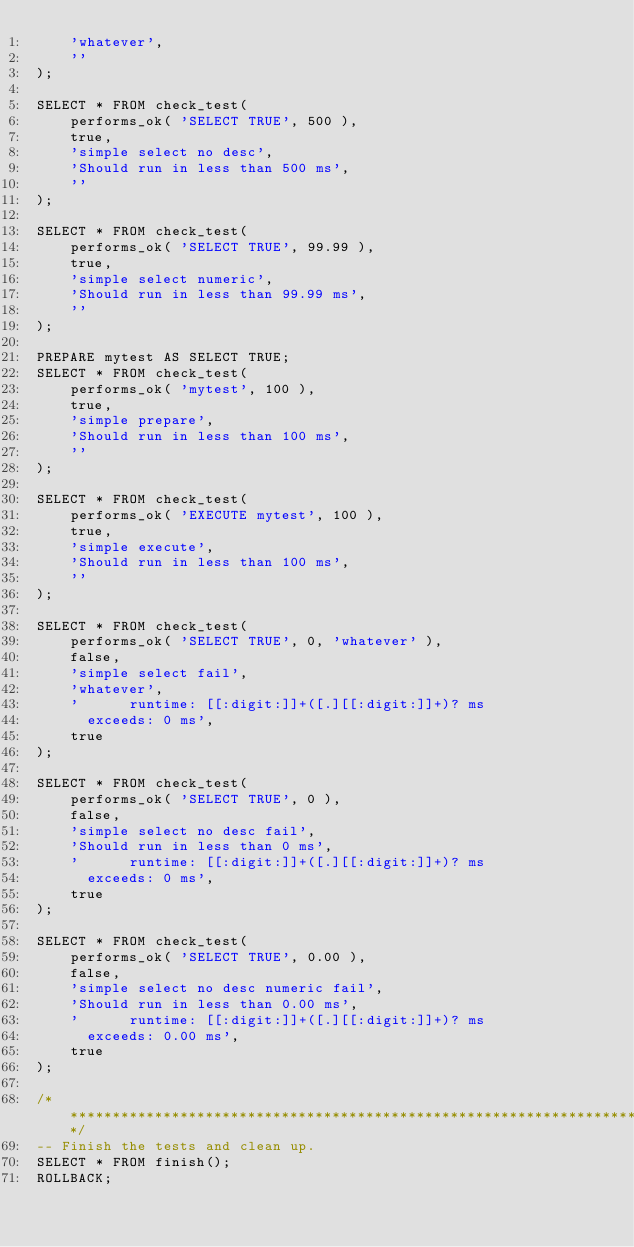<code> <loc_0><loc_0><loc_500><loc_500><_SQL_>    'whatever',
    ''
);

SELECT * FROM check_test(
    performs_ok( 'SELECT TRUE', 500 ),
    true,
    'simple select no desc',
    'Should run in less than 500 ms',
    ''
);

SELECT * FROM check_test(
    performs_ok( 'SELECT TRUE', 99.99 ),
    true,
    'simple select numeric',
    'Should run in less than 99.99 ms',
    ''
);

PREPARE mytest AS SELECT TRUE;
SELECT * FROM check_test(
    performs_ok( 'mytest', 100 ),
    true,
    'simple prepare',
    'Should run in less than 100 ms',
    ''
);

SELECT * FROM check_test(
    performs_ok( 'EXECUTE mytest', 100 ),
    true,
    'simple execute',
    'Should run in less than 100 ms',
    ''
);

SELECT * FROM check_test(
    performs_ok( 'SELECT TRUE', 0, 'whatever' ),
    false,
    'simple select fail',
    'whatever',
    '      runtime: [[:digit:]]+([.][[:digit:]]+)? ms
      exceeds: 0 ms',
    true
);

SELECT * FROM check_test(
    performs_ok( 'SELECT TRUE', 0 ),
    false,
    'simple select no desc fail',
    'Should run in less than 0 ms',
    '      runtime: [[:digit:]]+([.][[:digit:]]+)? ms
      exceeds: 0 ms',
    true
);

SELECT * FROM check_test(
    performs_ok( 'SELECT TRUE', 0.00 ),
    false,
    'simple select no desc numeric fail',
    'Should run in less than 0.00 ms',
    '      runtime: [[:digit:]]+([.][[:digit:]]+)? ms
      exceeds: 0.00 ms',
    true
);

/****************************************************************************/
-- Finish the tests and clean up.
SELECT * FROM finish();
ROLLBACK;
</code> 